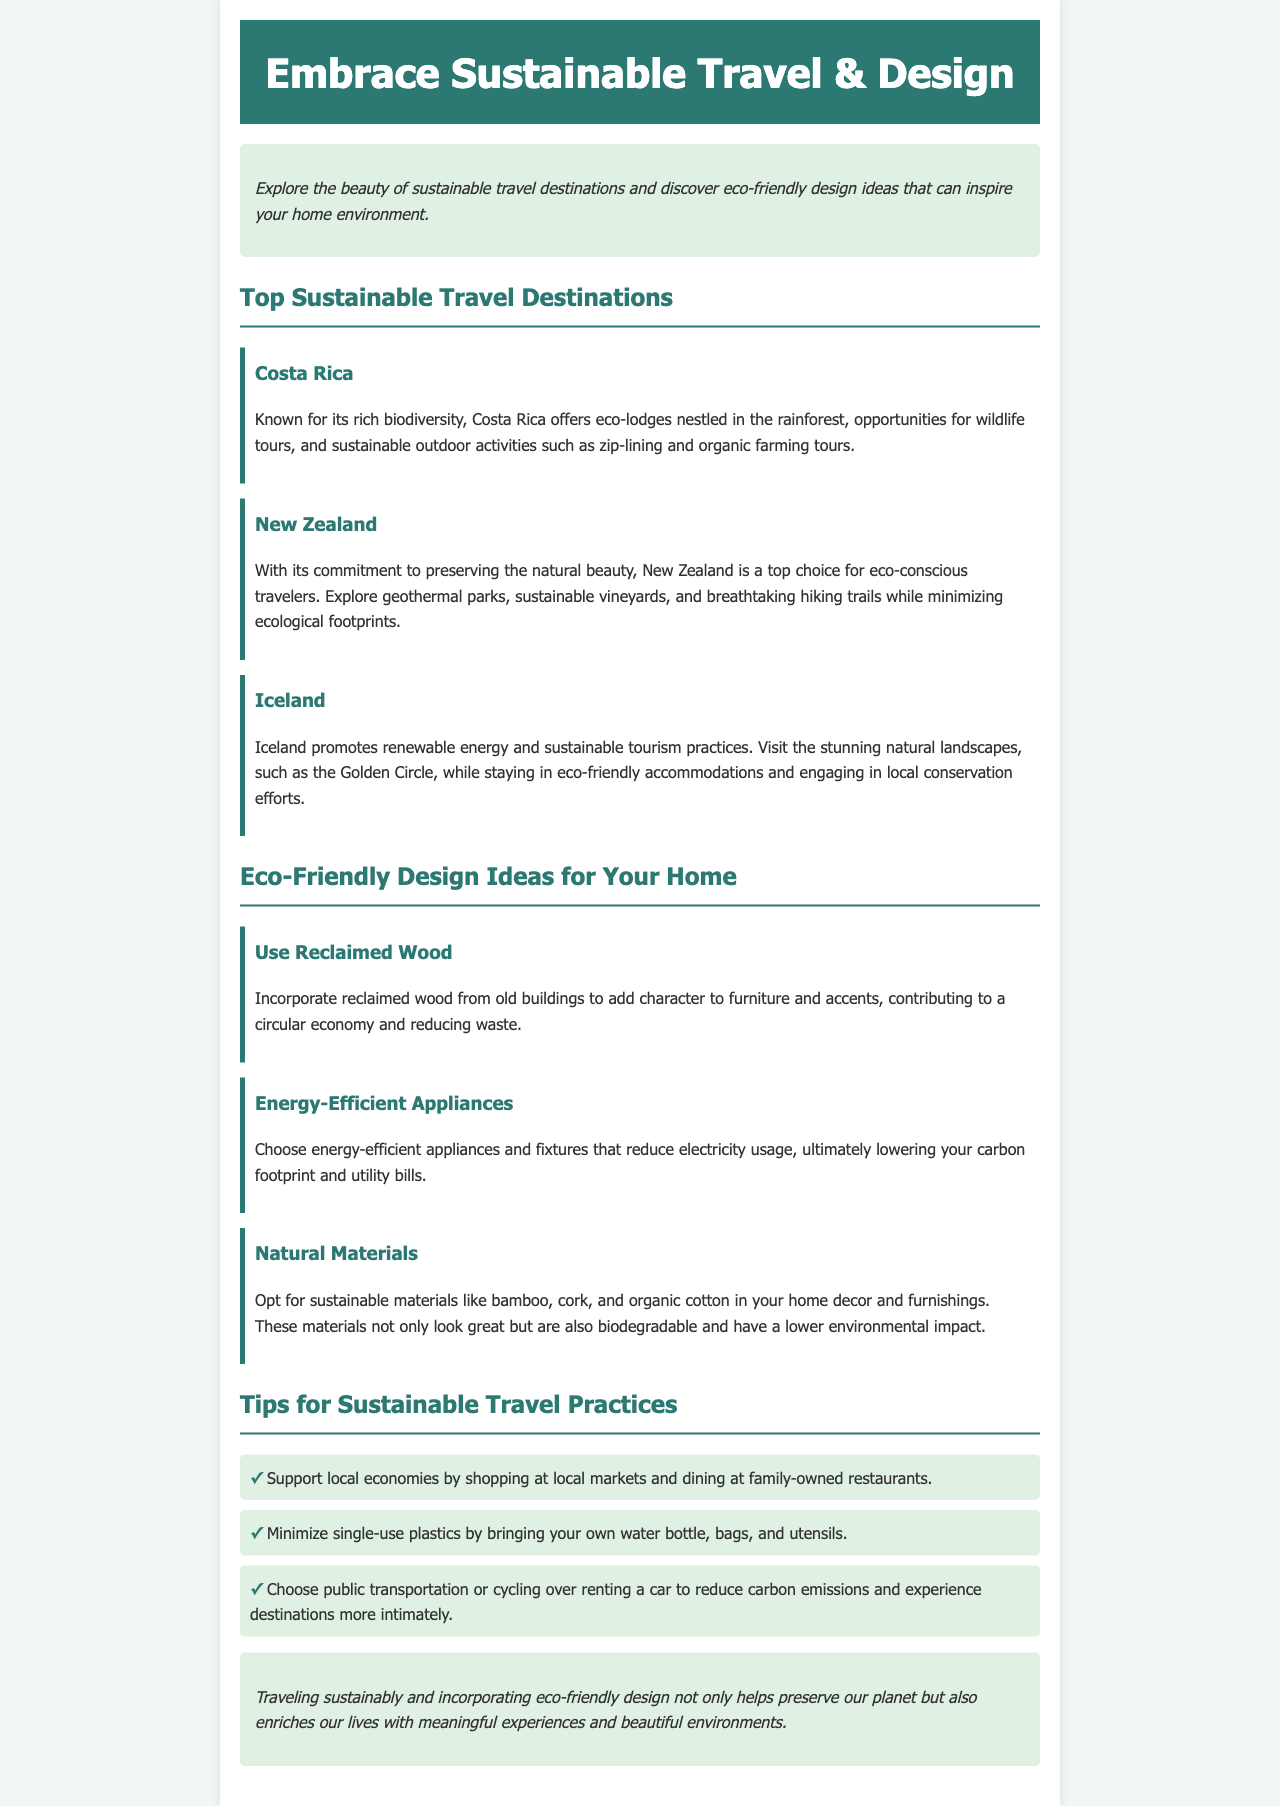what is the first sustainable travel destination mentioned? The first sustainable travel destination listed is Costa Rica.
Answer: Costa Rica how many eco-friendly design ideas are discussed? There are three eco-friendly design ideas presented in the document.
Answer: 3 what type of materials are suggested for home decor? The suggested materials for home decor include sustainable options like bamboo, cork, and organic cotton.
Answer: bamboo, cork, and organic cotton which country is known for geothermal parks? New Zealand is specifically noted for its geothermal parks.
Answer: New Zealand what is a recommended practice to reduce carbon emissions while traveling? Choosing public transportation or cycling is recommended to reduce carbon emissions.
Answer: public transportation or cycling what is the color of the header background? The header background color is #2c7873.
Answer: #2c7873 how does the document suggest supporting local economies? The document suggests supporting local economies by shopping at local markets and dining at family-owned restaurants.
Answer: shopping at local markets and dining at family-owned restaurants what is the overarching theme of the document? The overarching theme is embracing sustainable travel and eco-friendly design practices.
Answer: sustainable travel and eco-friendly design 